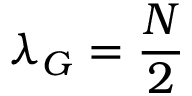<formula> <loc_0><loc_0><loc_500><loc_500>\lambda _ { G } = \frac { N } { 2 }</formula> 